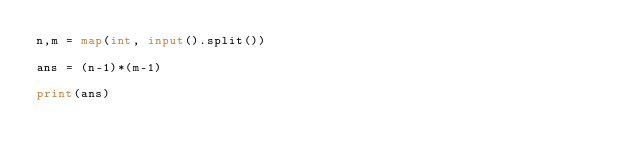<code> <loc_0><loc_0><loc_500><loc_500><_Python_>n,m = map(int, input().split())

ans = (n-1)*(m-1)

print(ans)
</code> 